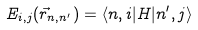Convert formula to latex. <formula><loc_0><loc_0><loc_500><loc_500>E _ { i , j } ( { \vec { r } } _ { n , n ^ { \prime } } ) = \langle n , i | H | n ^ { \prime } , j \rangle</formula> 